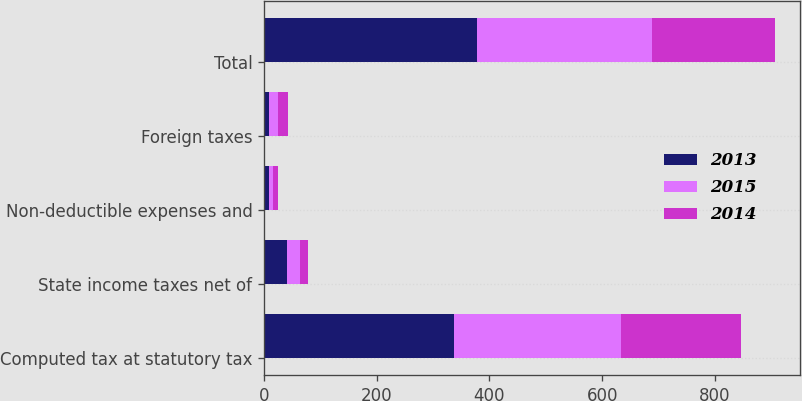Convert chart to OTSL. <chart><loc_0><loc_0><loc_500><loc_500><stacked_bar_chart><ecel><fcel>Computed tax at statutory tax<fcel>State income taxes net of<fcel>Non-deductible expenses and<fcel>Foreign taxes<fcel>Total<nl><fcel>2013<fcel>337<fcel>41<fcel>8<fcel>8<fcel>378<nl><fcel>2015<fcel>297<fcel>22<fcel>8<fcel>17<fcel>310<nl><fcel>2014<fcel>212<fcel>15<fcel>8<fcel>17<fcel>218<nl></chart> 